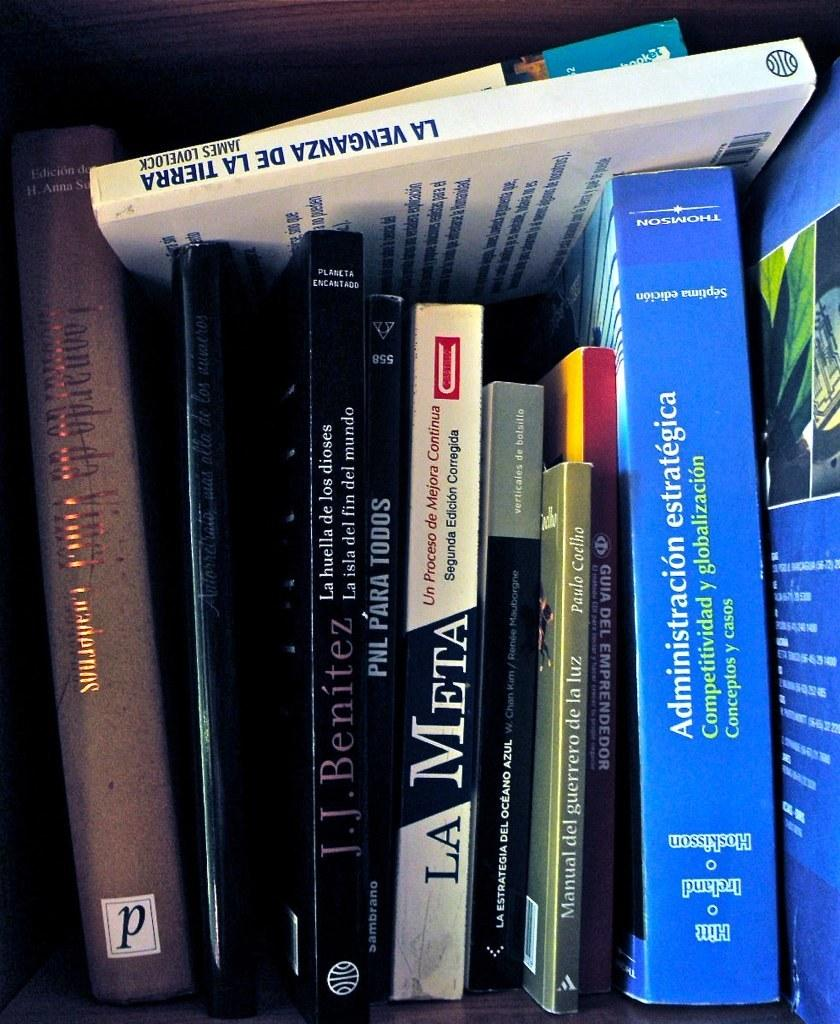<image>
Summarize the visual content of the image. Several books on a shelf with titles like La Meta. 